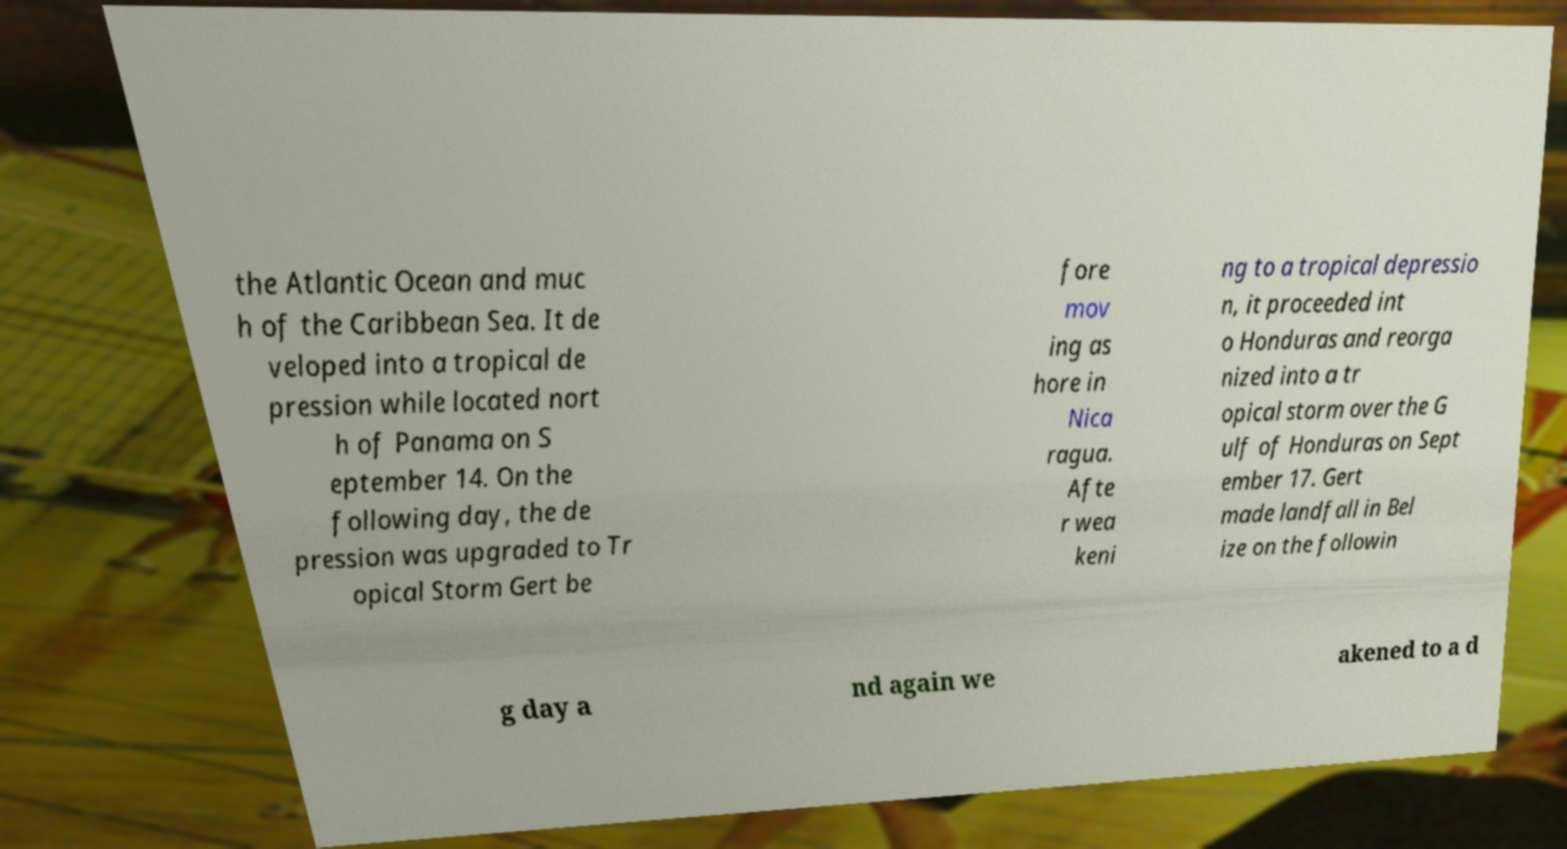Could you extract and type out the text from this image? the Atlantic Ocean and muc h of the Caribbean Sea. It de veloped into a tropical de pression while located nort h of Panama on S eptember 14. On the following day, the de pression was upgraded to Tr opical Storm Gert be fore mov ing as hore in Nica ragua. Afte r wea keni ng to a tropical depressio n, it proceeded int o Honduras and reorga nized into a tr opical storm over the G ulf of Honduras on Sept ember 17. Gert made landfall in Bel ize on the followin g day a nd again we akened to a d 